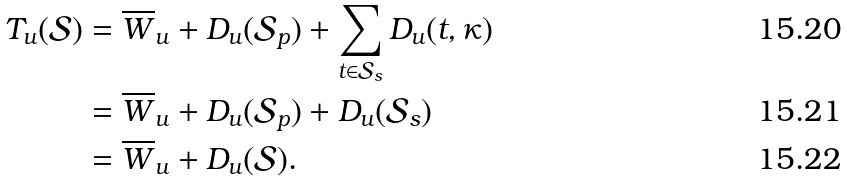Convert formula to latex. <formula><loc_0><loc_0><loc_500><loc_500>T _ { u } ( \mathcal { S } ) & = \overline { W } _ { u } + D _ { u } ( \mathcal { S } _ { p } ) + \sum _ { t \in \mathcal { S } _ { s } } D _ { u } ( t , \kappa ) \\ & = \overline { W } _ { u } + D _ { u } ( \mathcal { S } _ { p } ) + D _ { u } ( \mathcal { S } _ { s } ) \\ & = \overline { W } _ { u } + D _ { u } ( \mathcal { S } ) .</formula> 